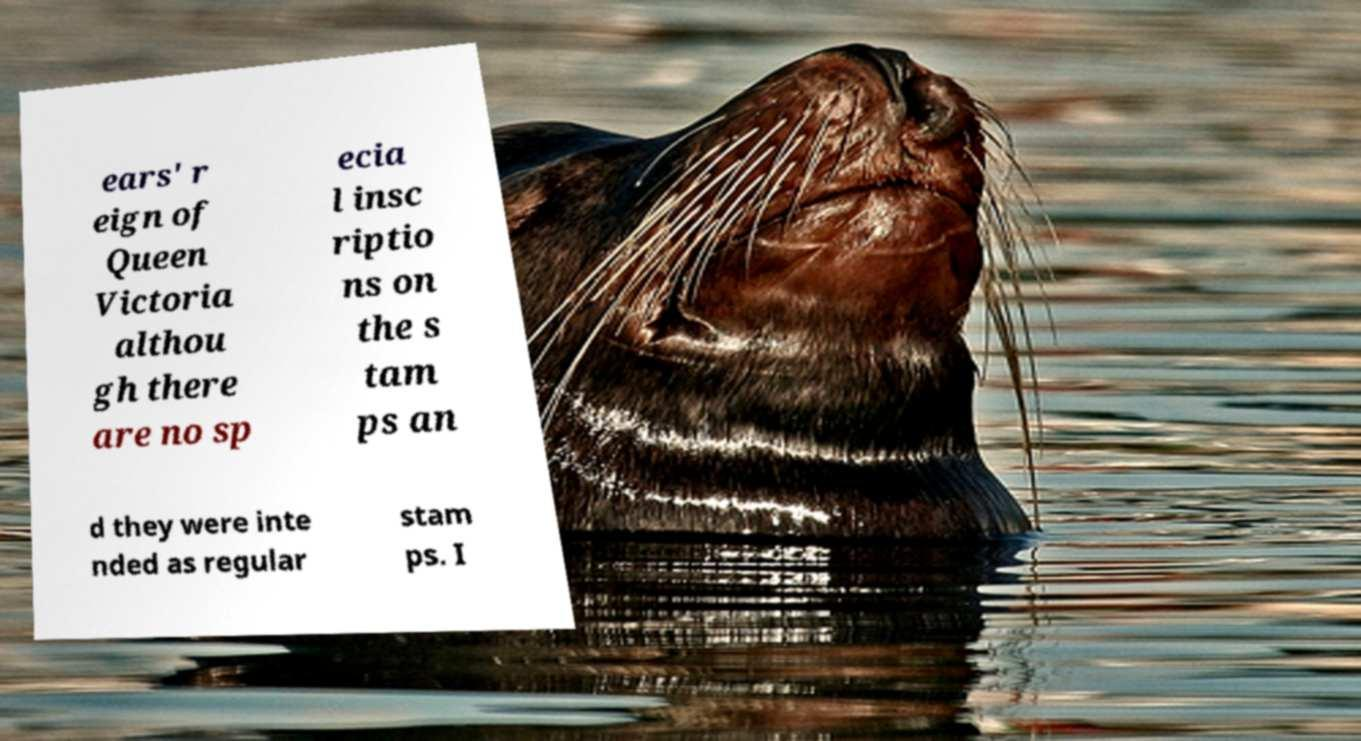There's text embedded in this image that I need extracted. Can you transcribe it verbatim? ears' r eign of Queen Victoria althou gh there are no sp ecia l insc riptio ns on the s tam ps an d they were inte nded as regular stam ps. I 